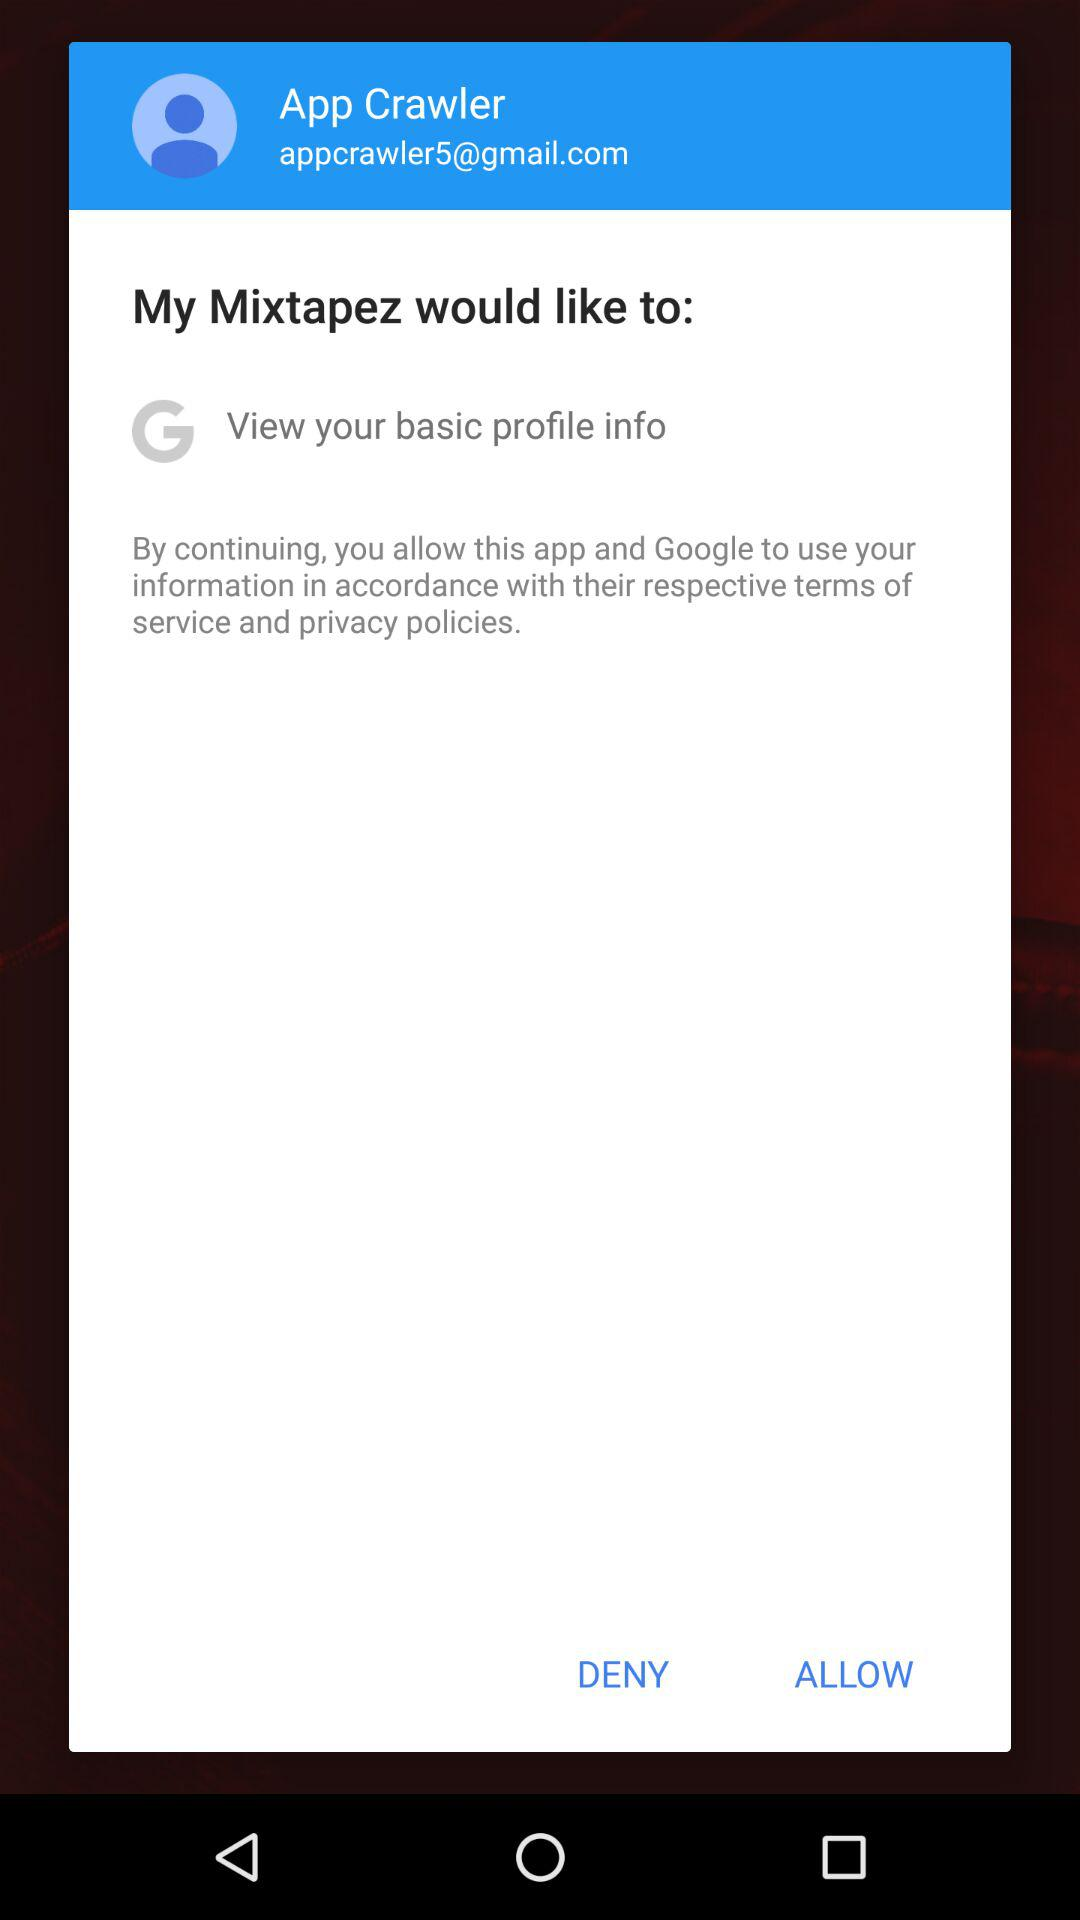What is the email address? The email address is appcrawler5@gmail.com. 